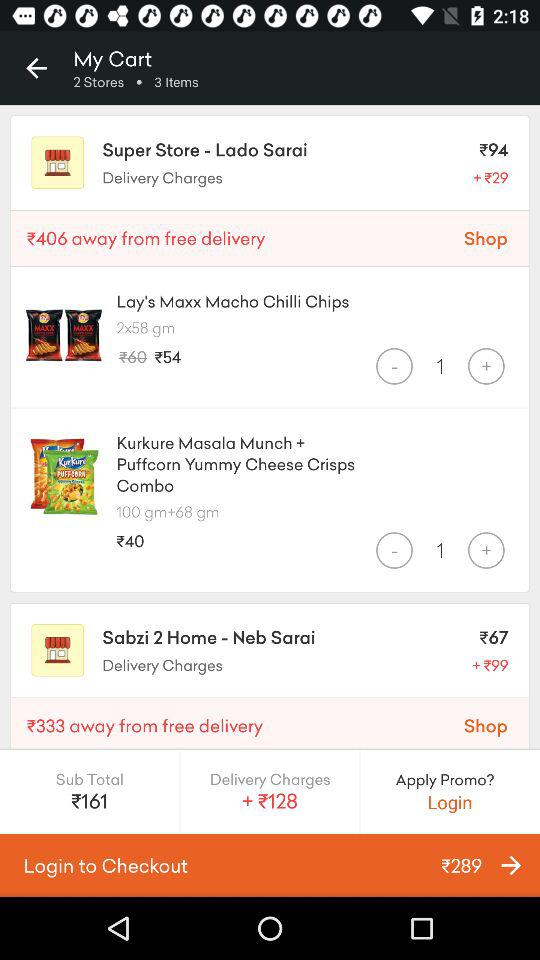What is the total payable amount? The total payable amount is $289. 